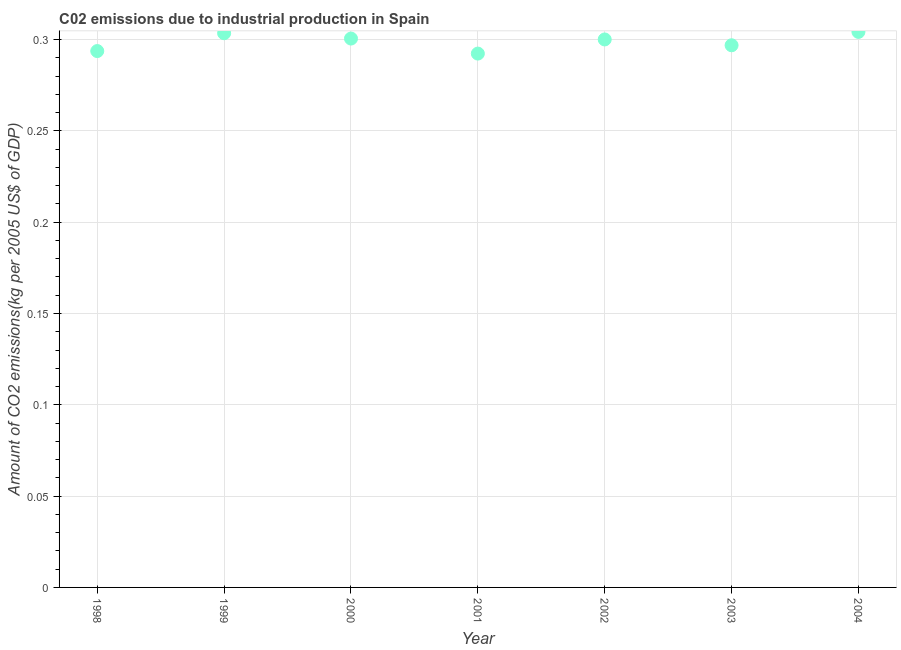What is the amount of co2 emissions in 2004?
Your answer should be very brief. 0.3. Across all years, what is the maximum amount of co2 emissions?
Your answer should be compact. 0.3. Across all years, what is the minimum amount of co2 emissions?
Your answer should be compact. 0.29. In which year was the amount of co2 emissions maximum?
Your response must be concise. 2004. In which year was the amount of co2 emissions minimum?
Your response must be concise. 2001. What is the sum of the amount of co2 emissions?
Your answer should be compact. 2.09. What is the difference between the amount of co2 emissions in 2002 and 2004?
Your answer should be compact. -0. What is the average amount of co2 emissions per year?
Provide a short and direct response. 0.3. What is the median amount of co2 emissions?
Provide a short and direct response. 0.3. What is the ratio of the amount of co2 emissions in 1999 to that in 2004?
Provide a short and direct response. 1. Is the amount of co2 emissions in 2000 less than that in 2004?
Keep it short and to the point. Yes. Is the difference between the amount of co2 emissions in 1999 and 2000 greater than the difference between any two years?
Provide a succinct answer. No. What is the difference between the highest and the second highest amount of co2 emissions?
Ensure brevity in your answer.  0. Is the sum of the amount of co2 emissions in 2003 and 2004 greater than the maximum amount of co2 emissions across all years?
Keep it short and to the point. Yes. What is the difference between the highest and the lowest amount of co2 emissions?
Your answer should be very brief. 0.01. How many dotlines are there?
Your answer should be very brief. 1. What is the difference between two consecutive major ticks on the Y-axis?
Provide a short and direct response. 0.05. Does the graph contain grids?
Give a very brief answer. Yes. What is the title of the graph?
Provide a short and direct response. C02 emissions due to industrial production in Spain. What is the label or title of the Y-axis?
Give a very brief answer. Amount of CO2 emissions(kg per 2005 US$ of GDP). What is the Amount of CO2 emissions(kg per 2005 US$ of GDP) in 1998?
Your response must be concise. 0.29. What is the Amount of CO2 emissions(kg per 2005 US$ of GDP) in 1999?
Ensure brevity in your answer.  0.3. What is the Amount of CO2 emissions(kg per 2005 US$ of GDP) in 2000?
Ensure brevity in your answer.  0.3. What is the Amount of CO2 emissions(kg per 2005 US$ of GDP) in 2001?
Keep it short and to the point. 0.29. What is the Amount of CO2 emissions(kg per 2005 US$ of GDP) in 2002?
Make the answer very short. 0.3. What is the Amount of CO2 emissions(kg per 2005 US$ of GDP) in 2003?
Provide a succinct answer. 0.3. What is the Amount of CO2 emissions(kg per 2005 US$ of GDP) in 2004?
Your answer should be very brief. 0.3. What is the difference between the Amount of CO2 emissions(kg per 2005 US$ of GDP) in 1998 and 1999?
Make the answer very short. -0.01. What is the difference between the Amount of CO2 emissions(kg per 2005 US$ of GDP) in 1998 and 2000?
Offer a terse response. -0.01. What is the difference between the Amount of CO2 emissions(kg per 2005 US$ of GDP) in 1998 and 2001?
Make the answer very short. 0. What is the difference between the Amount of CO2 emissions(kg per 2005 US$ of GDP) in 1998 and 2002?
Give a very brief answer. -0.01. What is the difference between the Amount of CO2 emissions(kg per 2005 US$ of GDP) in 1998 and 2003?
Offer a terse response. -0. What is the difference between the Amount of CO2 emissions(kg per 2005 US$ of GDP) in 1998 and 2004?
Your response must be concise. -0.01. What is the difference between the Amount of CO2 emissions(kg per 2005 US$ of GDP) in 1999 and 2000?
Provide a succinct answer. 0. What is the difference between the Amount of CO2 emissions(kg per 2005 US$ of GDP) in 1999 and 2001?
Ensure brevity in your answer.  0.01. What is the difference between the Amount of CO2 emissions(kg per 2005 US$ of GDP) in 1999 and 2002?
Make the answer very short. 0. What is the difference between the Amount of CO2 emissions(kg per 2005 US$ of GDP) in 1999 and 2003?
Keep it short and to the point. 0.01. What is the difference between the Amount of CO2 emissions(kg per 2005 US$ of GDP) in 1999 and 2004?
Make the answer very short. -0. What is the difference between the Amount of CO2 emissions(kg per 2005 US$ of GDP) in 2000 and 2001?
Make the answer very short. 0.01. What is the difference between the Amount of CO2 emissions(kg per 2005 US$ of GDP) in 2000 and 2002?
Give a very brief answer. 0. What is the difference between the Amount of CO2 emissions(kg per 2005 US$ of GDP) in 2000 and 2003?
Make the answer very short. 0. What is the difference between the Amount of CO2 emissions(kg per 2005 US$ of GDP) in 2000 and 2004?
Offer a terse response. -0. What is the difference between the Amount of CO2 emissions(kg per 2005 US$ of GDP) in 2001 and 2002?
Ensure brevity in your answer.  -0.01. What is the difference between the Amount of CO2 emissions(kg per 2005 US$ of GDP) in 2001 and 2003?
Give a very brief answer. -0. What is the difference between the Amount of CO2 emissions(kg per 2005 US$ of GDP) in 2001 and 2004?
Your answer should be compact. -0.01. What is the difference between the Amount of CO2 emissions(kg per 2005 US$ of GDP) in 2002 and 2003?
Offer a terse response. 0. What is the difference between the Amount of CO2 emissions(kg per 2005 US$ of GDP) in 2002 and 2004?
Provide a short and direct response. -0. What is the difference between the Amount of CO2 emissions(kg per 2005 US$ of GDP) in 2003 and 2004?
Your response must be concise. -0.01. What is the ratio of the Amount of CO2 emissions(kg per 2005 US$ of GDP) in 1998 to that in 1999?
Give a very brief answer. 0.97. What is the ratio of the Amount of CO2 emissions(kg per 2005 US$ of GDP) in 1998 to that in 2000?
Your response must be concise. 0.98. What is the ratio of the Amount of CO2 emissions(kg per 2005 US$ of GDP) in 1998 to that in 2001?
Your response must be concise. 1. What is the ratio of the Amount of CO2 emissions(kg per 2005 US$ of GDP) in 1998 to that in 2003?
Ensure brevity in your answer.  0.99. What is the ratio of the Amount of CO2 emissions(kg per 2005 US$ of GDP) in 1999 to that in 2000?
Keep it short and to the point. 1.01. What is the ratio of the Amount of CO2 emissions(kg per 2005 US$ of GDP) in 1999 to that in 2001?
Ensure brevity in your answer.  1.04. What is the ratio of the Amount of CO2 emissions(kg per 2005 US$ of GDP) in 1999 to that in 2002?
Ensure brevity in your answer.  1.01. What is the ratio of the Amount of CO2 emissions(kg per 2005 US$ of GDP) in 1999 to that in 2003?
Your answer should be very brief. 1.02. What is the ratio of the Amount of CO2 emissions(kg per 2005 US$ of GDP) in 2000 to that in 2001?
Offer a terse response. 1.03. What is the ratio of the Amount of CO2 emissions(kg per 2005 US$ of GDP) in 2000 to that in 2002?
Give a very brief answer. 1. What is the ratio of the Amount of CO2 emissions(kg per 2005 US$ of GDP) in 2000 to that in 2004?
Provide a succinct answer. 0.99. What is the ratio of the Amount of CO2 emissions(kg per 2005 US$ of GDP) in 2001 to that in 2003?
Your response must be concise. 0.98. What is the ratio of the Amount of CO2 emissions(kg per 2005 US$ of GDP) in 2003 to that in 2004?
Your response must be concise. 0.98. 